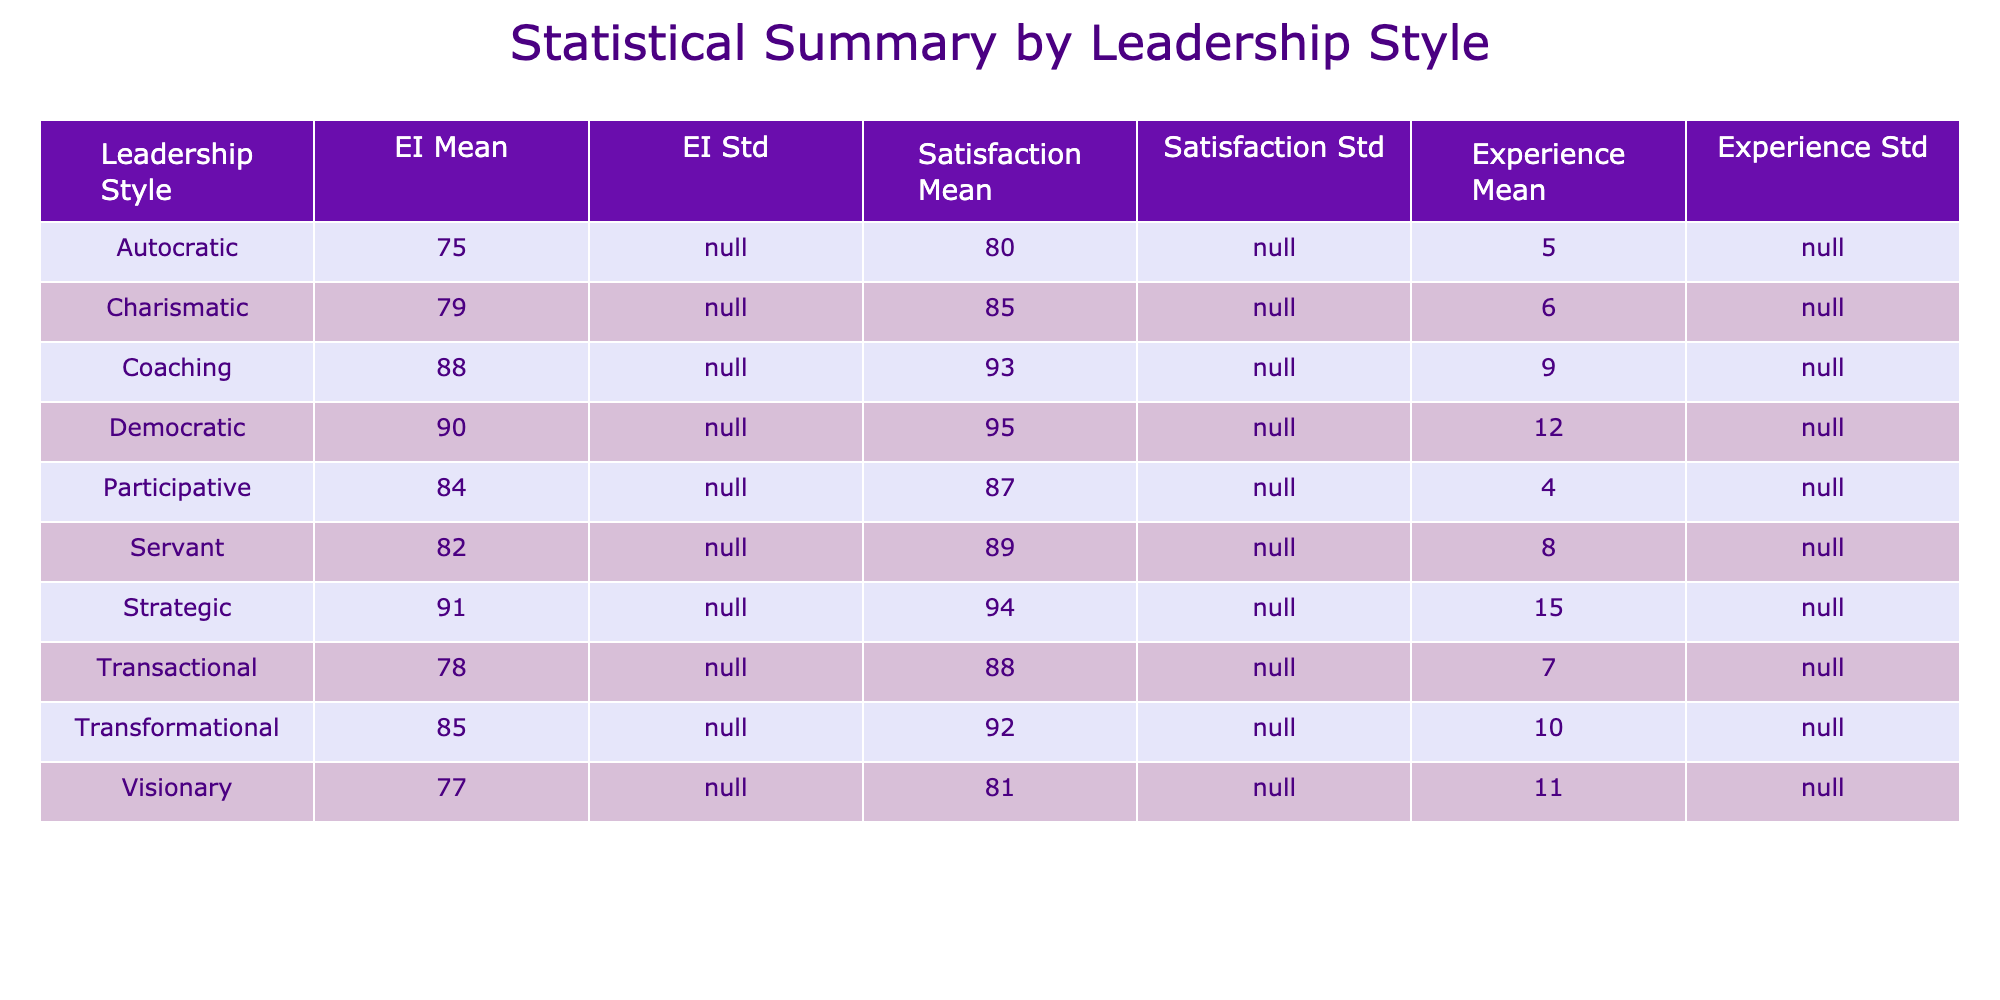What is the highest Emotional Intelligence Score in the table? By examining the 'Emotional Intelligence Score' column, Isabella Young has the highest score listed at 91.
Answer: 91 What is the average Team Satisfaction Score for the Democratic leadership style? For Democratic leaders, only Linda Garcia is listed with a Team Satisfaction Score of 95, so the average is also 95, as it's a single value.
Answer: 95 Which leadership style has the highest average Years of Experience? Calculating the mean for each leadership style, the Strategic style (Isabella Young) has 15 years, which is the highest when compared with others.
Answer: Strategic Is the average Emotional Intelligence Score for Servant leadership style greater than 80? The only entry for Servant leadership is Sophia Martinez with an Emotional Intelligence Score of 82. Since 82 is greater than 80, the answer is yes.
Answer: Yes How does the Emotional Intelligence Score relate to Team Satisfaction Score for the Transactional leadership style? For Transactional leadership (James Robinson), the Emotional Intelligence Score is 78 and the Team Satisfaction Score is 88. Thus, there's a positive correlation since satisfaction is higher despite a lower EI score.
Answer: Positive correlation What is the sum of Years of Experience for all team members with a Transformational leadership style? The only member listed under Transformational is Anna Thompson with 10 years. Therefore, the sum is simply 10.
Answer: 10 Is it true that all leadership styles have an Emotional Intelligence Score greater than 70? Reviewing the table, all listed Emotional Intelligence Scores are above 70, confirming that the statement is true.
Answer: True Which role has the lowest Emotional Intelligence Score and what is the score? Scanning the list, Michael Wilson as a Software Engineer has the lowest Emotional Intelligence Score of 75.
Answer: Software Engineer, 75 What is the average Emotional Intelligence Score across all team members? Adding all the scores (85 + 78 + 90 + 75 + 82 + 79 + 88 + 84 + 77 + 91) gives  835. Dividing by the number of members (10) results in an average score of 83.5.
Answer: 83.5 